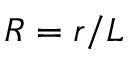<formula> <loc_0><loc_0><loc_500><loc_500>R = r / L</formula> 